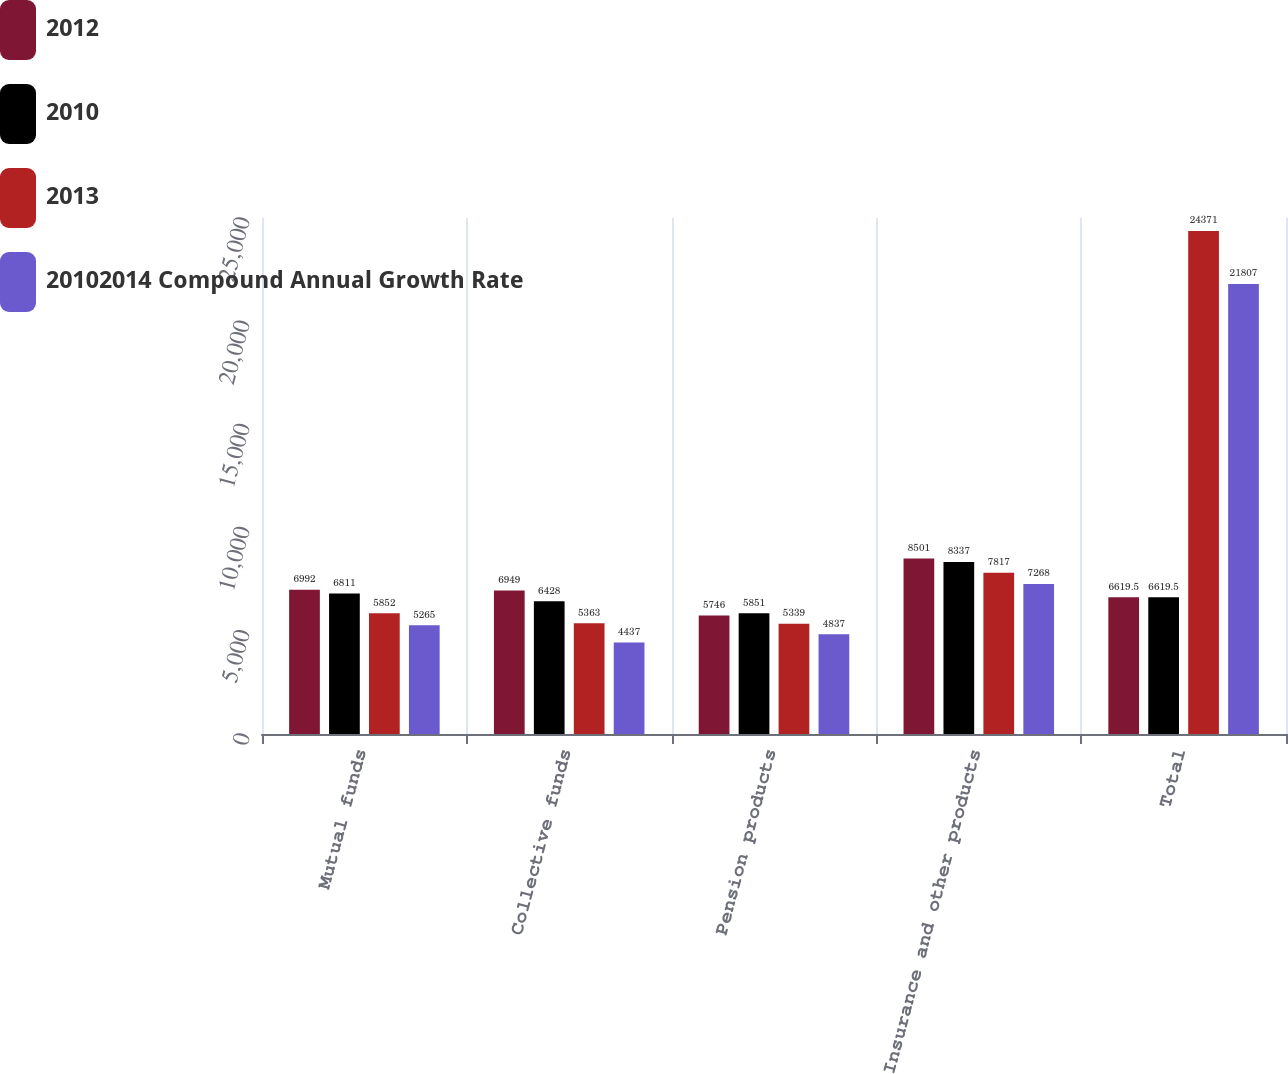Convert chart. <chart><loc_0><loc_0><loc_500><loc_500><stacked_bar_chart><ecel><fcel>Mutual funds<fcel>Collective funds<fcel>Pension products<fcel>Insurance and other products<fcel>Total<nl><fcel>2012<fcel>6992<fcel>6949<fcel>5746<fcel>8501<fcel>6619.5<nl><fcel>2010<fcel>6811<fcel>6428<fcel>5851<fcel>8337<fcel>6619.5<nl><fcel>2013<fcel>5852<fcel>5363<fcel>5339<fcel>7817<fcel>24371<nl><fcel>20102014 Compound Annual Growth Rate<fcel>5265<fcel>4437<fcel>4837<fcel>7268<fcel>21807<nl></chart> 